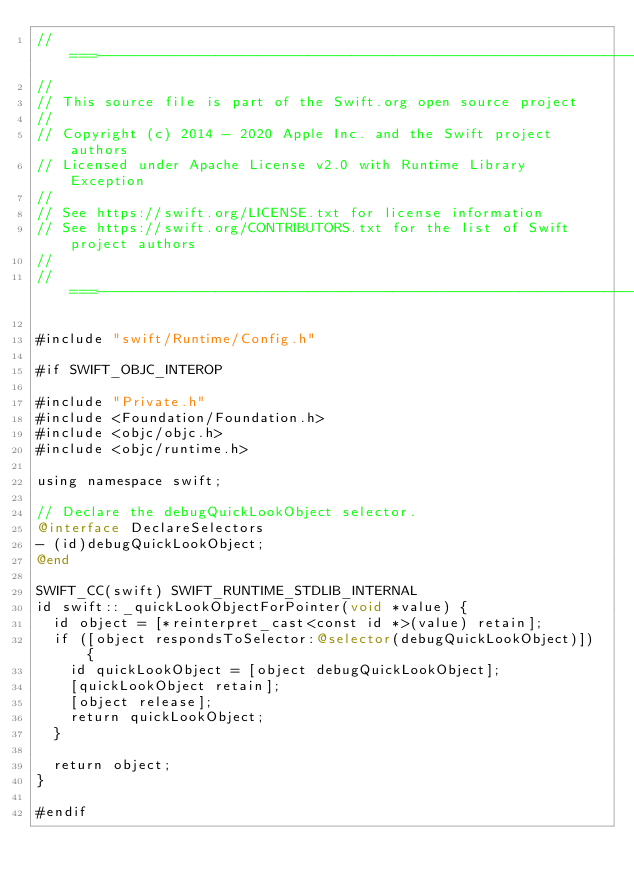<code> <loc_0><loc_0><loc_500><loc_500><_ObjectiveC_>//===----------------------------------------------------------------------===//
//
// This source file is part of the Swift.org open source project
//
// Copyright (c) 2014 - 2020 Apple Inc. and the Swift project authors
// Licensed under Apache License v2.0 with Runtime Library Exception
//
// See https://swift.org/LICENSE.txt for license information
// See https://swift.org/CONTRIBUTORS.txt for the list of Swift project authors
//
//===----------------------------------------------------------------------===//

#include "swift/Runtime/Config.h"

#if SWIFT_OBJC_INTEROP

#include "Private.h"
#include <Foundation/Foundation.h>
#include <objc/objc.h>
#include <objc/runtime.h>

using namespace swift;

// Declare the debugQuickLookObject selector.
@interface DeclareSelectors
- (id)debugQuickLookObject;
@end

SWIFT_CC(swift) SWIFT_RUNTIME_STDLIB_INTERNAL
id swift::_quickLookObjectForPointer(void *value) {
  id object = [*reinterpret_cast<const id *>(value) retain];
  if ([object respondsToSelector:@selector(debugQuickLookObject)]) {
    id quickLookObject = [object debugQuickLookObject];
    [quickLookObject retain];
    [object release];
    return quickLookObject;
  }

  return object;
}

#endif
</code> 